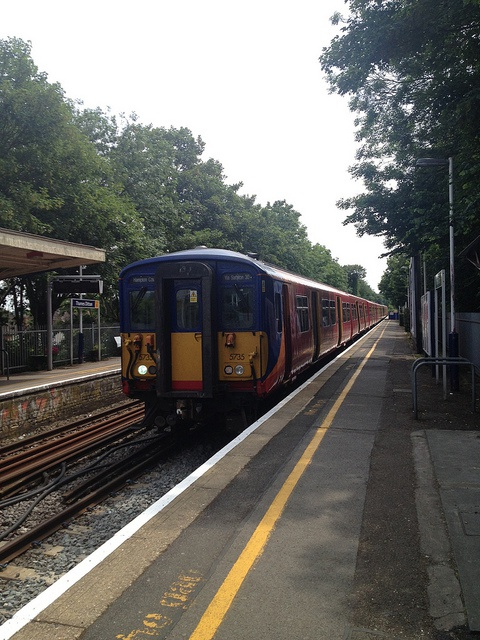Describe the objects in this image and their specific colors. I can see train in white, black, maroon, and gray tones, people in white, black, maroon, gray, and darkgray tones, and people in white, black, and gray tones in this image. 